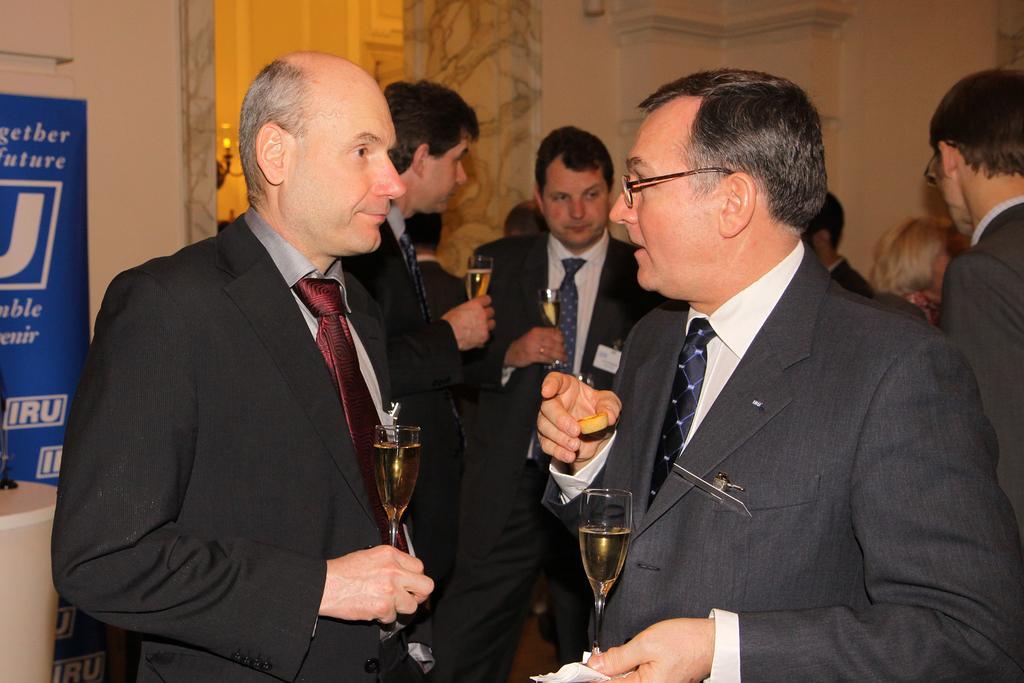Could you give a brief overview of what you see in this image? Group of people standing and these persons are holding glass with drink and wear tie. On the background we can see wall,light,banner. 